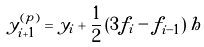Convert formula to latex. <formula><loc_0><loc_0><loc_500><loc_500>y ^ { ( p ) } _ { i + 1 } = y _ { i } + \frac { 1 } { 2 } \left ( 3 f _ { i } - f _ { i - 1 } \right ) h</formula> 